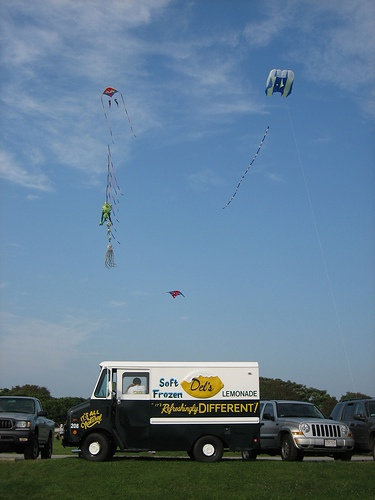Describe the objects in this image and their specific colors. I can see truck in gray, black, lightgray, and darkgray tones, car in gray, black, darkgray, and darkblue tones, truck in gray, black, darkgray, and darkblue tones, truck in gray, black, and purple tones, and car in gray, black, darkblue, and blue tones in this image. 